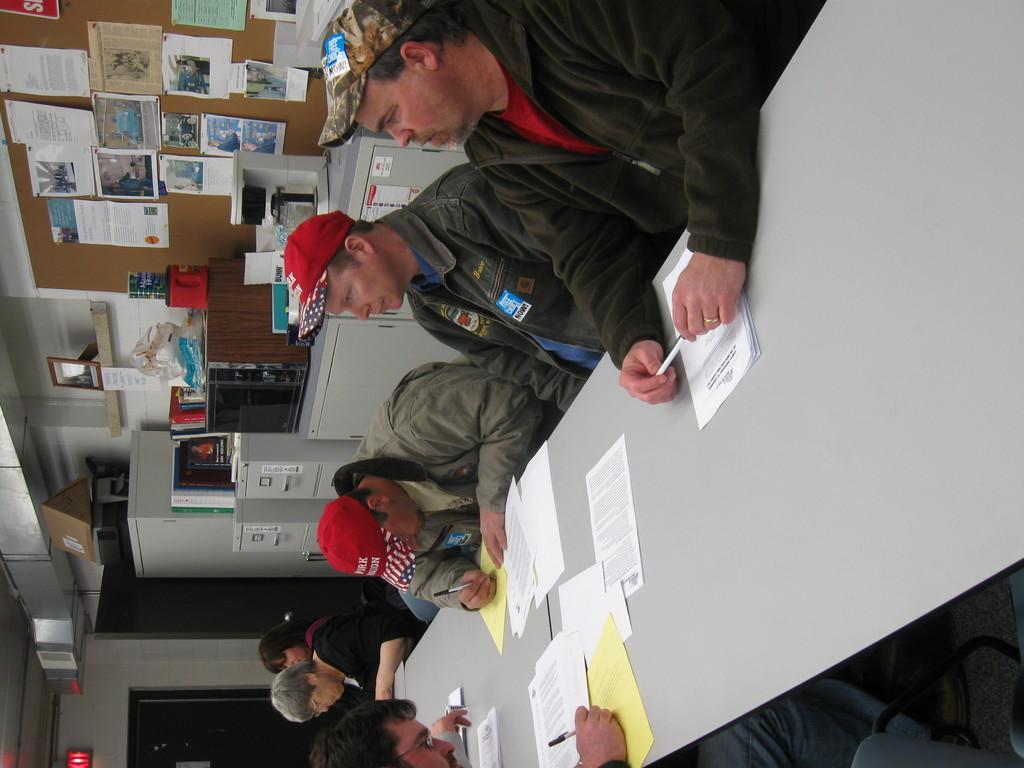Please provide a concise description of this image. In this image there are group of people sitting on the chairs around the table and writing on the writing on the paper, which is on the table. Behind them there is a wall on which there are so many posters and articles. On the left side there is a refrigerator beside the door. On the left side bottom there is an exit board. It seems like this image is taken inside the room. 